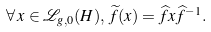Convert formula to latex. <formula><loc_0><loc_0><loc_500><loc_500>\forall \, x \in \mathcal { L } _ { g , 0 } ( H ) , \, \widetilde { f } ( x ) = \widehat { f } x \widehat { f } ^ { - 1 } .</formula> 